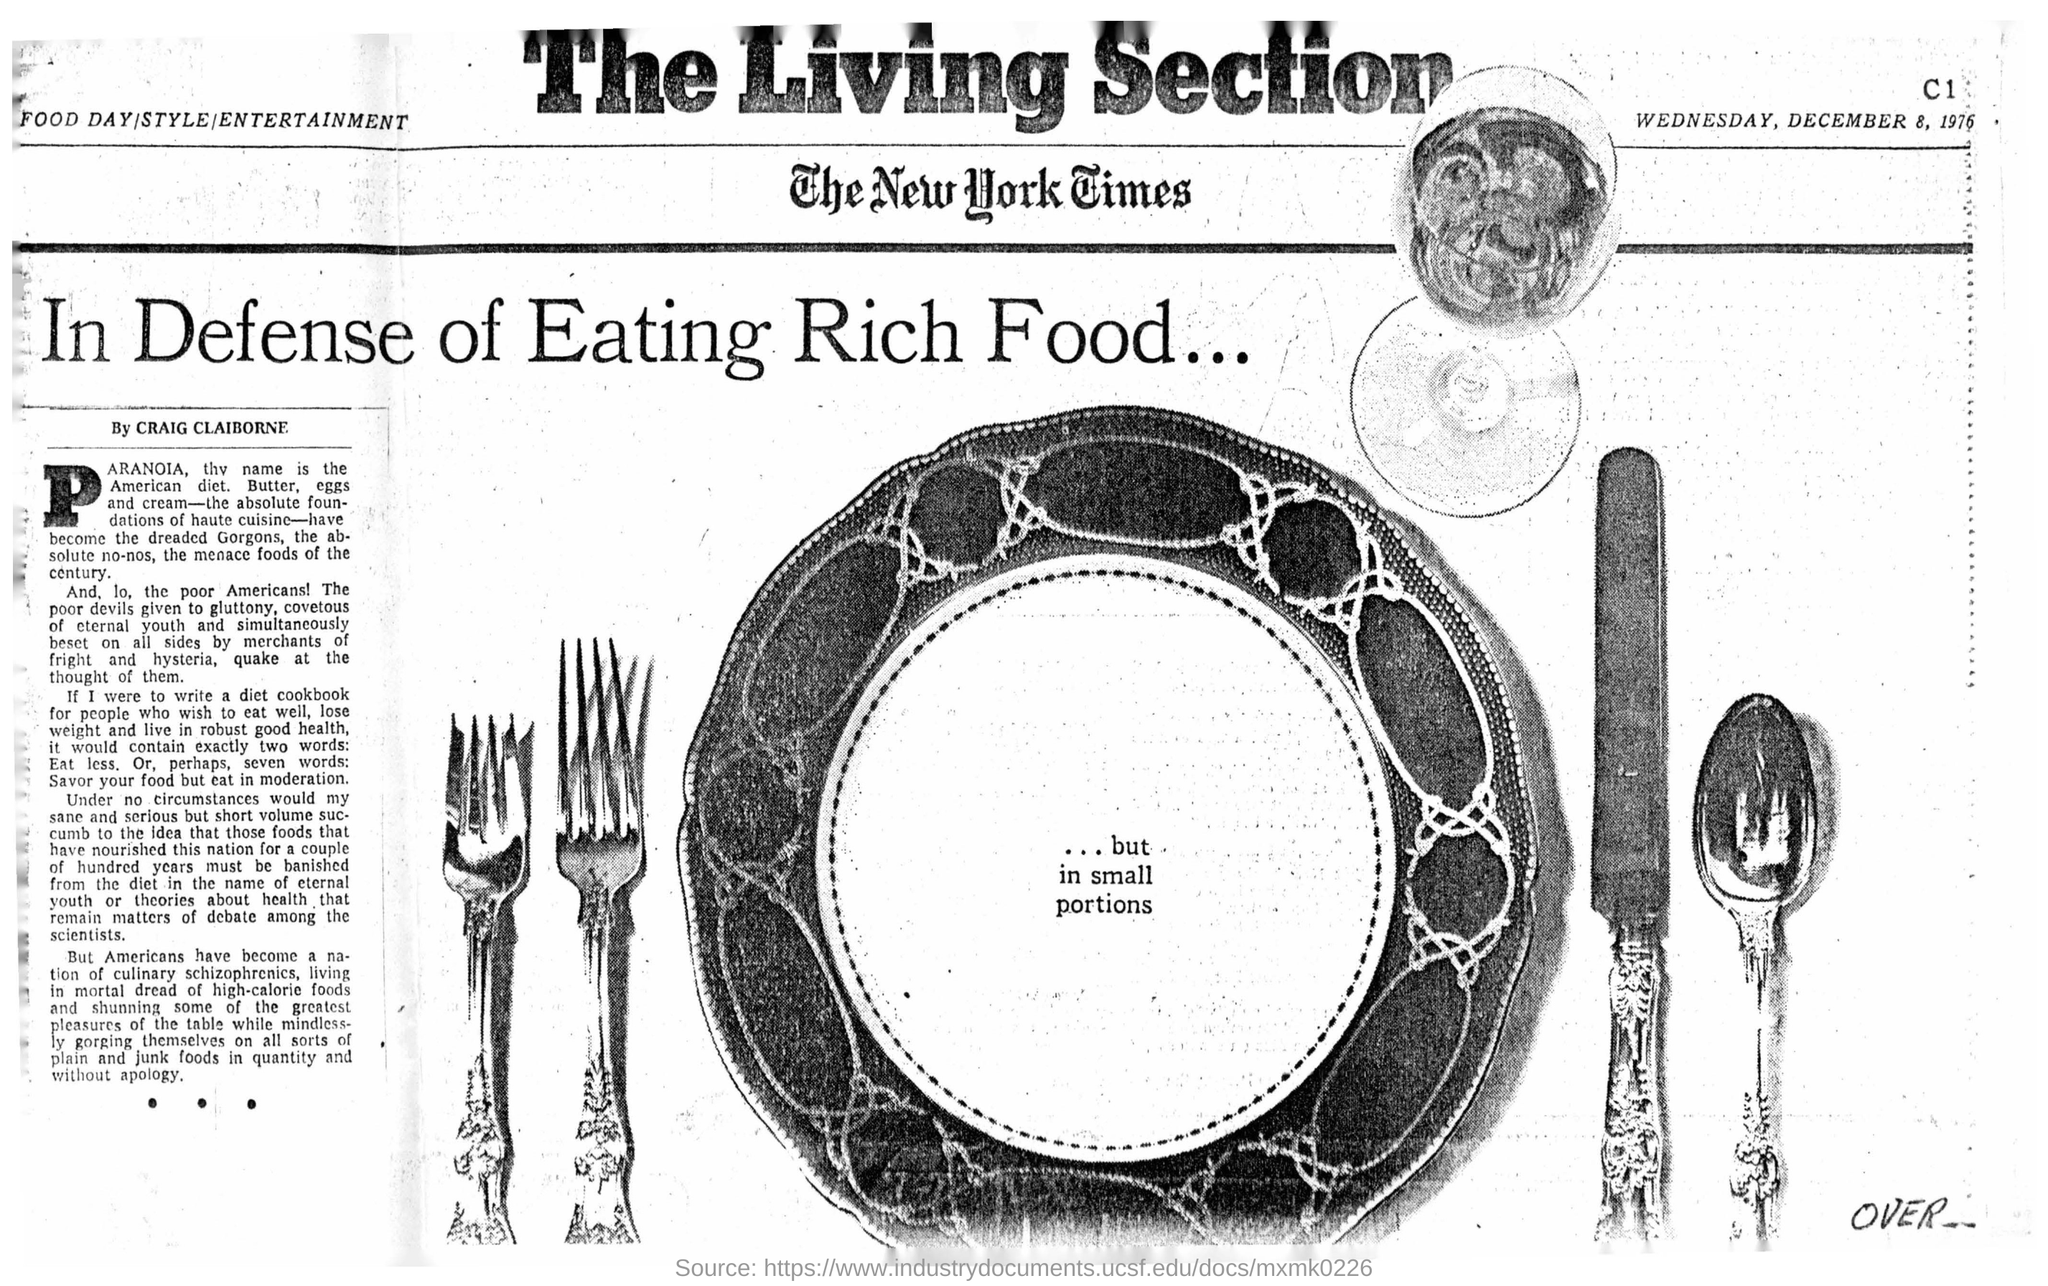What is the name of the newspaper?
Your answer should be very brief. The New York times. What is the head line of this news?
Your response must be concise. In Defense of Eating Rich Food... Who is the News writer?
Make the answer very short. CRAIG CLAIBORNE. What is the date mentioned in the newspaper?
Offer a terse response. WEDNESDAY, DECEMBER 8, 1976. 